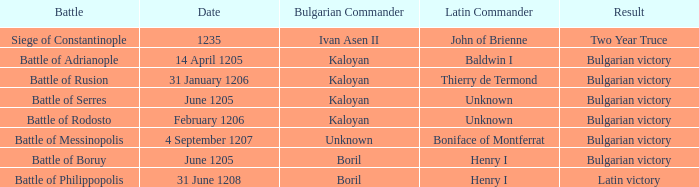On what Date was Henry I Latin Commander of the Battle of Boruy? June 1205. 